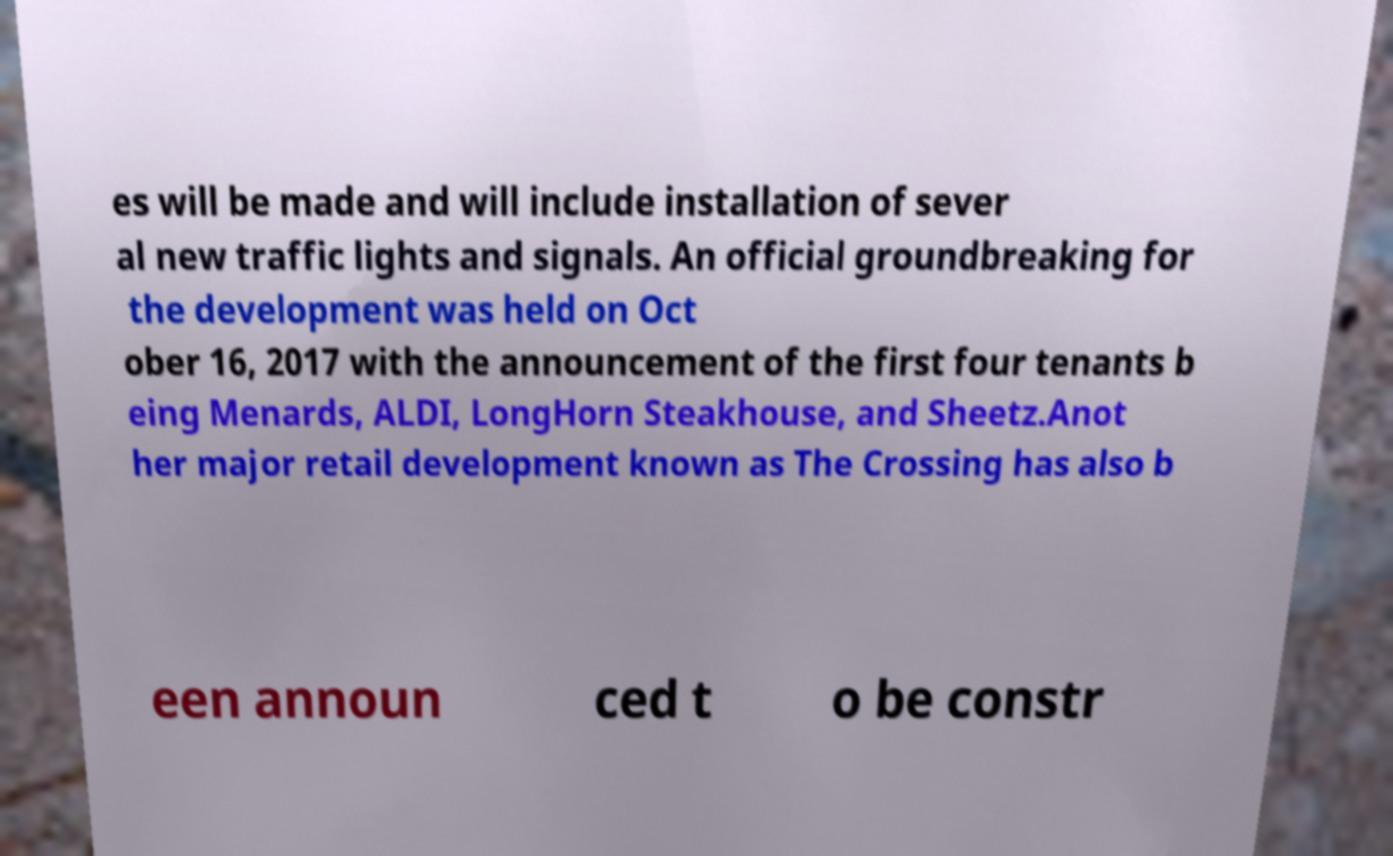Can you read and provide the text displayed in the image?This photo seems to have some interesting text. Can you extract and type it out for me? es will be made and will include installation of sever al new traffic lights and signals. An official groundbreaking for the development was held on Oct ober 16, 2017 with the announcement of the first four tenants b eing Menards, ALDI, LongHorn Steakhouse, and Sheetz.Anot her major retail development known as The Crossing has also b een announ ced t o be constr 